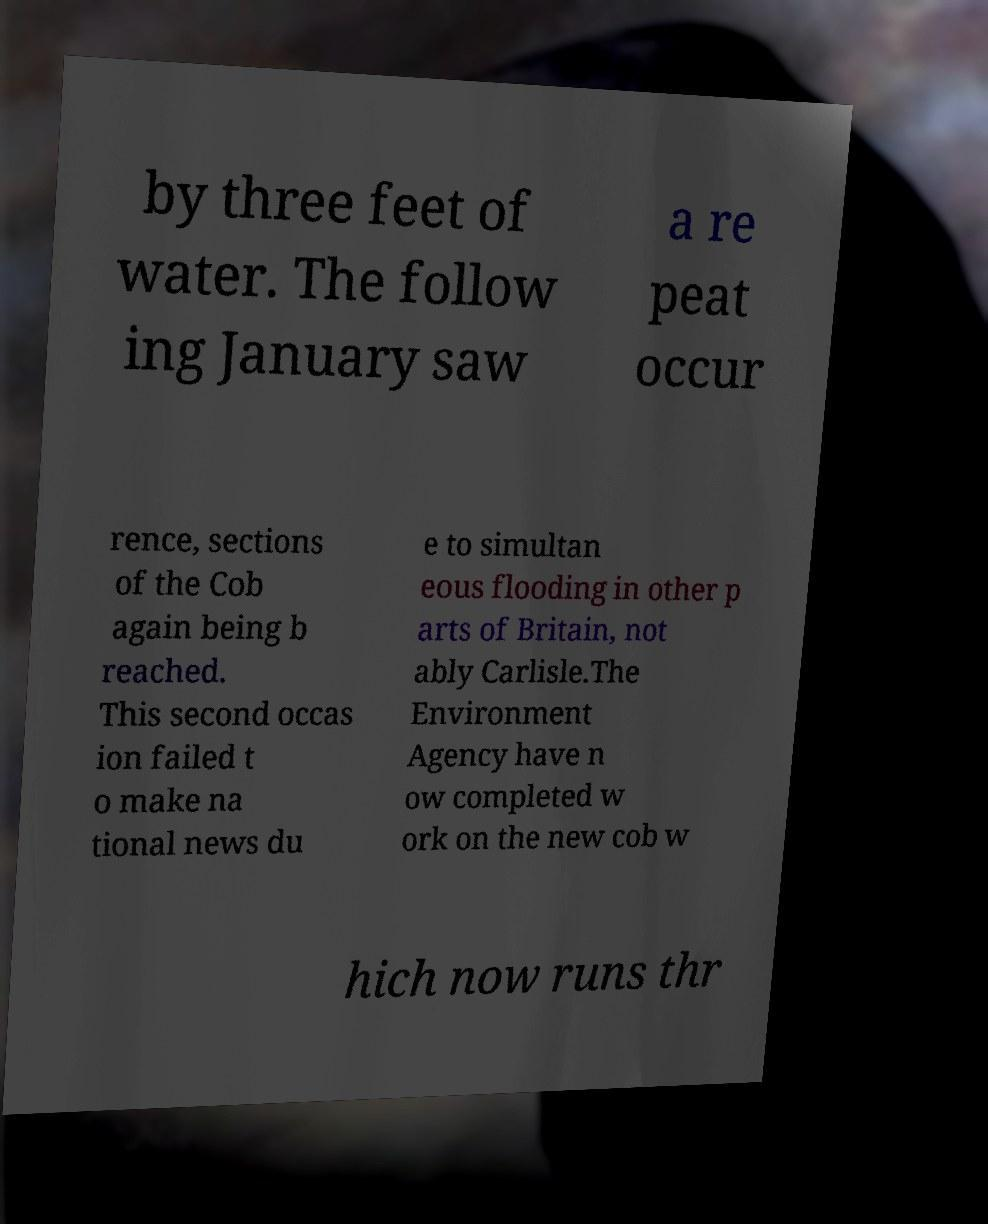Can you read and provide the text displayed in the image?This photo seems to have some interesting text. Can you extract and type it out for me? by three feet of water. The follow ing January saw a re peat occur rence, sections of the Cob again being b reached. This second occas ion failed t o make na tional news du e to simultan eous flooding in other p arts of Britain, not ably Carlisle.The Environment Agency have n ow completed w ork on the new cob w hich now runs thr 